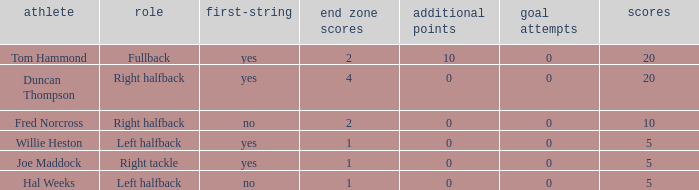What is the lowest number of field goals when the points were less than 5? None. 